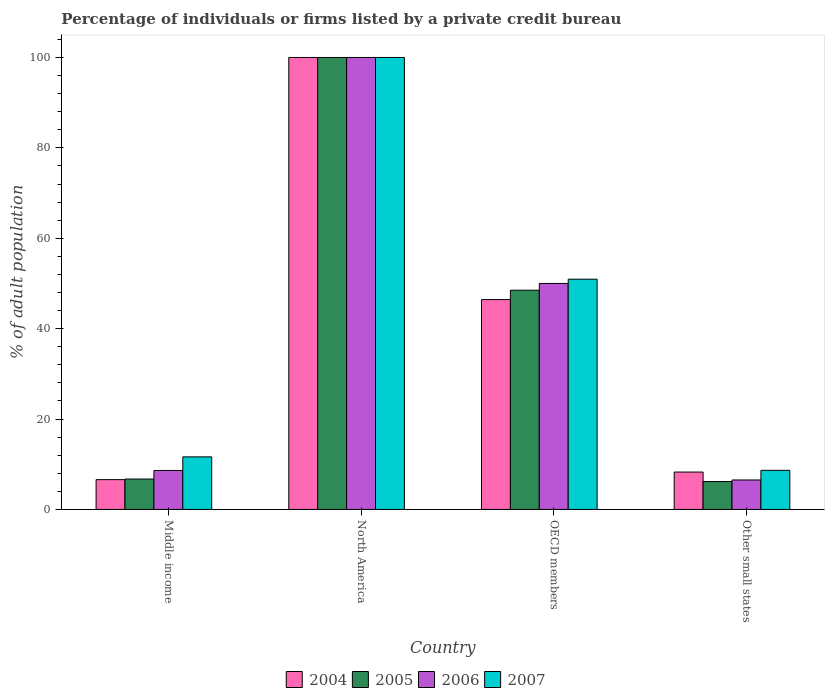How many different coloured bars are there?
Provide a succinct answer. 4. Are the number of bars per tick equal to the number of legend labels?
Give a very brief answer. Yes. Are the number of bars on each tick of the X-axis equal?
Keep it short and to the point. Yes. How many bars are there on the 1st tick from the left?
Offer a terse response. 4. How many bars are there on the 3rd tick from the right?
Offer a terse response. 4. What is the label of the 2nd group of bars from the left?
Provide a succinct answer. North America. What is the percentage of population listed by a private credit bureau in 2004 in Other small states?
Your answer should be compact. 8.28. Across all countries, what is the minimum percentage of population listed by a private credit bureau in 2004?
Offer a very short reply. 6.6. In which country was the percentage of population listed by a private credit bureau in 2004 maximum?
Your answer should be very brief. North America. In which country was the percentage of population listed by a private credit bureau in 2004 minimum?
Offer a terse response. Middle income. What is the total percentage of population listed by a private credit bureau in 2007 in the graph?
Keep it short and to the point. 171.24. What is the difference between the percentage of population listed by a private credit bureau in 2004 in North America and that in Other small states?
Make the answer very short. 91.72. What is the difference between the percentage of population listed by a private credit bureau in 2007 in Other small states and the percentage of population listed by a private credit bureau in 2004 in Middle income?
Provide a succinct answer. 2.06. What is the average percentage of population listed by a private credit bureau in 2004 per country?
Give a very brief answer. 40.33. What is the difference between the percentage of population listed by a private credit bureau of/in 2004 and percentage of population listed by a private credit bureau of/in 2005 in OECD members?
Your response must be concise. -2.07. What is the ratio of the percentage of population listed by a private credit bureau in 2005 in Middle income to that in OECD members?
Give a very brief answer. 0.14. Is the difference between the percentage of population listed by a private credit bureau in 2004 in OECD members and Other small states greater than the difference between the percentage of population listed by a private credit bureau in 2005 in OECD members and Other small states?
Your answer should be very brief. No. What is the difference between the highest and the second highest percentage of population listed by a private credit bureau in 2005?
Ensure brevity in your answer.  -51.5. What is the difference between the highest and the lowest percentage of population listed by a private credit bureau in 2007?
Your answer should be very brief. 91.34. What does the 3rd bar from the left in Other small states represents?
Your answer should be compact. 2006. What does the 3rd bar from the right in Middle income represents?
Give a very brief answer. 2005. Is it the case that in every country, the sum of the percentage of population listed by a private credit bureau in 2007 and percentage of population listed by a private credit bureau in 2004 is greater than the percentage of population listed by a private credit bureau in 2005?
Your response must be concise. Yes. How many bars are there?
Offer a very short reply. 16. Are all the bars in the graph horizontal?
Make the answer very short. No. What is the difference between two consecutive major ticks on the Y-axis?
Offer a terse response. 20. Are the values on the major ticks of Y-axis written in scientific E-notation?
Keep it short and to the point. No. Does the graph contain any zero values?
Give a very brief answer. No. Does the graph contain grids?
Give a very brief answer. No. Where does the legend appear in the graph?
Offer a very short reply. Bottom center. How many legend labels are there?
Offer a very short reply. 4. How are the legend labels stacked?
Give a very brief answer. Horizontal. What is the title of the graph?
Keep it short and to the point. Percentage of individuals or firms listed by a private credit bureau. What is the label or title of the X-axis?
Keep it short and to the point. Country. What is the label or title of the Y-axis?
Give a very brief answer. % of adult population. What is the % of adult population in 2004 in Middle income?
Your response must be concise. 6.6. What is the % of adult population of 2005 in Middle income?
Your answer should be compact. 6.73. What is the % of adult population in 2006 in Middle income?
Give a very brief answer. 8.62. What is the % of adult population in 2007 in Middle income?
Provide a succinct answer. 11.63. What is the % of adult population in 2006 in North America?
Offer a terse response. 100. What is the % of adult population of 2007 in North America?
Your answer should be compact. 100. What is the % of adult population of 2004 in OECD members?
Provide a succinct answer. 46.43. What is the % of adult population in 2005 in OECD members?
Keep it short and to the point. 48.5. What is the % of adult population in 2006 in OECD members?
Offer a terse response. 50. What is the % of adult population in 2007 in OECD members?
Your response must be concise. 50.95. What is the % of adult population of 2004 in Other small states?
Provide a succinct answer. 8.28. What is the % of adult population in 2005 in Other small states?
Provide a succinct answer. 6.18. What is the % of adult population in 2006 in Other small states?
Provide a short and direct response. 6.52. What is the % of adult population of 2007 in Other small states?
Provide a succinct answer. 8.66. Across all countries, what is the maximum % of adult population of 2004?
Keep it short and to the point. 100. Across all countries, what is the minimum % of adult population in 2004?
Provide a short and direct response. 6.6. Across all countries, what is the minimum % of adult population of 2005?
Offer a very short reply. 6.18. Across all countries, what is the minimum % of adult population in 2006?
Provide a short and direct response. 6.52. Across all countries, what is the minimum % of adult population in 2007?
Keep it short and to the point. 8.66. What is the total % of adult population in 2004 in the graph?
Give a very brief answer. 161.3. What is the total % of adult population of 2005 in the graph?
Keep it short and to the point. 161.41. What is the total % of adult population in 2006 in the graph?
Offer a terse response. 165.15. What is the total % of adult population of 2007 in the graph?
Offer a very short reply. 171.24. What is the difference between the % of adult population of 2004 in Middle income and that in North America?
Your response must be concise. -93.4. What is the difference between the % of adult population in 2005 in Middle income and that in North America?
Provide a succinct answer. -93.27. What is the difference between the % of adult population in 2006 in Middle income and that in North America?
Offer a terse response. -91.38. What is the difference between the % of adult population of 2007 in Middle income and that in North America?
Keep it short and to the point. -88.37. What is the difference between the % of adult population of 2004 in Middle income and that in OECD members?
Your response must be concise. -39.84. What is the difference between the % of adult population in 2005 in Middle income and that in OECD members?
Your answer should be compact. -41.77. What is the difference between the % of adult population of 2006 in Middle income and that in OECD members?
Your response must be concise. -41.38. What is the difference between the % of adult population in 2007 in Middle income and that in OECD members?
Your response must be concise. -39.31. What is the difference between the % of adult population of 2004 in Middle income and that in Other small states?
Your response must be concise. -1.68. What is the difference between the % of adult population in 2005 in Middle income and that in Other small states?
Offer a very short reply. 0.55. What is the difference between the % of adult population of 2006 in Middle income and that in Other small states?
Offer a very short reply. 2.1. What is the difference between the % of adult population in 2007 in Middle income and that in Other small states?
Offer a very short reply. 2.98. What is the difference between the % of adult population in 2004 in North America and that in OECD members?
Keep it short and to the point. 53.57. What is the difference between the % of adult population in 2005 in North America and that in OECD members?
Give a very brief answer. 51.5. What is the difference between the % of adult population in 2006 in North America and that in OECD members?
Make the answer very short. 50. What is the difference between the % of adult population in 2007 in North America and that in OECD members?
Offer a very short reply. 49.05. What is the difference between the % of adult population of 2004 in North America and that in Other small states?
Your answer should be compact. 91.72. What is the difference between the % of adult population in 2005 in North America and that in Other small states?
Provide a succinct answer. 93.82. What is the difference between the % of adult population in 2006 in North America and that in Other small states?
Offer a very short reply. 93.48. What is the difference between the % of adult population of 2007 in North America and that in Other small states?
Provide a succinct answer. 91.34. What is the difference between the % of adult population in 2004 in OECD members and that in Other small states?
Provide a succinct answer. 38.16. What is the difference between the % of adult population of 2005 in OECD members and that in Other small states?
Offer a very short reply. 42.33. What is the difference between the % of adult population of 2006 in OECD members and that in Other small states?
Your answer should be very brief. 43.48. What is the difference between the % of adult population in 2007 in OECD members and that in Other small states?
Your answer should be very brief. 42.29. What is the difference between the % of adult population of 2004 in Middle income and the % of adult population of 2005 in North America?
Provide a short and direct response. -93.4. What is the difference between the % of adult population in 2004 in Middle income and the % of adult population in 2006 in North America?
Make the answer very short. -93.4. What is the difference between the % of adult population of 2004 in Middle income and the % of adult population of 2007 in North America?
Your response must be concise. -93.4. What is the difference between the % of adult population of 2005 in Middle income and the % of adult population of 2006 in North America?
Make the answer very short. -93.27. What is the difference between the % of adult population of 2005 in Middle income and the % of adult population of 2007 in North America?
Give a very brief answer. -93.27. What is the difference between the % of adult population of 2006 in Middle income and the % of adult population of 2007 in North America?
Give a very brief answer. -91.38. What is the difference between the % of adult population of 2004 in Middle income and the % of adult population of 2005 in OECD members?
Give a very brief answer. -41.91. What is the difference between the % of adult population of 2004 in Middle income and the % of adult population of 2006 in OECD members?
Provide a succinct answer. -43.4. What is the difference between the % of adult population of 2004 in Middle income and the % of adult population of 2007 in OECD members?
Your answer should be very brief. -44.35. What is the difference between the % of adult population of 2005 in Middle income and the % of adult population of 2006 in OECD members?
Your response must be concise. -43.27. What is the difference between the % of adult population in 2005 in Middle income and the % of adult population in 2007 in OECD members?
Offer a terse response. -44.22. What is the difference between the % of adult population in 2006 in Middle income and the % of adult population in 2007 in OECD members?
Provide a succinct answer. -42.32. What is the difference between the % of adult population in 2004 in Middle income and the % of adult population in 2005 in Other small states?
Your answer should be compact. 0.42. What is the difference between the % of adult population of 2004 in Middle income and the % of adult population of 2006 in Other small states?
Provide a succinct answer. 0.07. What is the difference between the % of adult population in 2004 in Middle income and the % of adult population in 2007 in Other small states?
Give a very brief answer. -2.06. What is the difference between the % of adult population of 2005 in Middle income and the % of adult population of 2006 in Other small states?
Provide a short and direct response. 0.21. What is the difference between the % of adult population of 2005 in Middle income and the % of adult population of 2007 in Other small states?
Provide a succinct answer. -1.93. What is the difference between the % of adult population of 2006 in Middle income and the % of adult population of 2007 in Other small states?
Offer a terse response. -0.03. What is the difference between the % of adult population in 2004 in North America and the % of adult population in 2005 in OECD members?
Offer a very short reply. 51.5. What is the difference between the % of adult population of 2004 in North America and the % of adult population of 2006 in OECD members?
Keep it short and to the point. 50. What is the difference between the % of adult population in 2004 in North America and the % of adult population in 2007 in OECD members?
Your answer should be compact. 49.05. What is the difference between the % of adult population in 2005 in North America and the % of adult population in 2006 in OECD members?
Your answer should be very brief. 50. What is the difference between the % of adult population in 2005 in North America and the % of adult population in 2007 in OECD members?
Your answer should be compact. 49.05. What is the difference between the % of adult population in 2006 in North America and the % of adult population in 2007 in OECD members?
Offer a terse response. 49.05. What is the difference between the % of adult population of 2004 in North America and the % of adult population of 2005 in Other small states?
Make the answer very short. 93.82. What is the difference between the % of adult population of 2004 in North America and the % of adult population of 2006 in Other small states?
Provide a succinct answer. 93.48. What is the difference between the % of adult population of 2004 in North America and the % of adult population of 2007 in Other small states?
Offer a very short reply. 91.34. What is the difference between the % of adult population of 2005 in North America and the % of adult population of 2006 in Other small states?
Your answer should be very brief. 93.48. What is the difference between the % of adult population of 2005 in North America and the % of adult population of 2007 in Other small states?
Provide a succinct answer. 91.34. What is the difference between the % of adult population of 2006 in North America and the % of adult population of 2007 in Other small states?
Offer a terse response. 91.34. What is the difference between the % of adult population in 2004 in OECD members and the % of adult population in 2005 in Other small states?
Your answer should be compact. 40.26. What is the difference between the % of adult population of 2004 in OECD members and the % of adult population of 2006 in Other small states?
Make the answer very short. 39.91. What is the difference between the % of adult population of 2004 in OECD members and the % of adult population of 2007 in Other small states?
Keep it short and to the point. 37.78. What is the difference between the % of adult population of 2005 in OECD members and the % of adult population of 2006 in Other small states?
Your response must be concise. 41.98. What is the difference between the % of adult population in 2005 in OECD members and the % of adult population in 2007 in Other small states?
Give a very brief answer. 39.85. What is the difference between the % of adult population in 2006 in OECD members and the % of adult population in 2007 in Other small states?
Your answer should be very brief. 41.34. What is the average % of adult population of 2004 per country?
Offer a very short reply. 40.33. What is the average % of adult population of 2005 per country?
Your response must be concise. 40.35. What is the average % of adult population of 2006 per country?
Give a very brief answer. 41.29. What is the average % of adult population in 2007 per country?
Ensure brevity in your answer.  42.81. What is the difference between the % of adult population of 2004 and % of adult population of 2005 in Middle income?
Provide a succinct answer. -0.13. What is the difference between the % of adult population of 2004 and % of adult population of 2006 in Middle income?
Ensure brevity in your answer.  -2.03. What is the difference between the % of adult population of 2004 and % of adult population of 2007 in Middle income?
Offer a terse response. -5.04. What is the difference between the % of adult population of 2005 and % of adult population of 2006 in Middle income?
Your response must be concise. -1.9. What is the difference between the % of adult population in 2005 and % of adult population in 2007 in Middle income?
Provide a short and direct response. -4.91. What is the difference between the % of adult population in 2006 and % of adult population in 2007 in Middle income?
Provide a succinct answer. -3.01. What is the difference between the % of adult population in 2004 and % of adult population in 2007 in North America?
Make the answer very short. 0. What is the difference between the % of adult population of 2004 and % of adult population of 2005 in OECD members?
Your answer should be compact. -2.07. What is the difference between the % of adult population of 2004 and % of adult population of 2006 in OECD members?
Provide a short and direct response. -3.57. What is the difference between the % of adult population in 2004 and % of adult population in 2007 in OECD members?
Keep it short and to the point. -4.51. What is the difference between the % of adult population in 2005 and % of adult population in 2006 in OECD members?
Give a very brief answer. -1.5. What is the difference between the % of adult population in 2005 and % of adult population in 2007 in OECD members?
Give a very brief answer. -2.44. What is the difference between the % of adult population in 2006 and % of adult population in 2007 in OECD members?
Your answer should be very brief. -0.95. What is the difference between the % of adult population in 2004 and % of adult population in 2005 in Other small states?
Keep it short and to the point. 2.1. What is the difference between the % of adult population in 2004 and % of adult population in 2006 in Other small states?
Your answer should be compact. 1.75. What is the difference between the % of adult population of 2004 and % of adult population of 2007 in Other small states?
Ensure brevity in your answer.  -0.38. What is the difference between the % of adult population of 2005 and % of adult population of 2006 in Other small states?
Your response must be concise. -0.35. What is the difference between the % of adult population of 2005 and % of adult population of 2007 in Other small states?
Your answer should be very brief. -2.48. What is the difference between the % of adult population of 2006 and % of adult population of 2007 in Other small states?
Your response must be concise. -2.13. What is the ratio of the % of adult population of 2004 in Middle income to that in North America?
Offer a terse response. 0.07. What is the ratio of the % of adult population in 2005 in Middle income to that in North America?
Provide a succinct answer. 0.07. What is the ratio of the % of adult population in 2006 in Middle income to that in North America?
Ensure brevity in your answer.  0.09. What is the ratio of the % of adult population in 2007 in Middle income to that in North America?
Provide a short and direct response. 0.12. What is the ratio of the % of adult population in 2004 in Middle income to that in OECD members?
Ensure brevity in your answer.  0.14. What is the ratio of the % of adult population of 2005 in Middle income to that in OECD members?
Provide a short and direct response. 0.14. What is the ratio of the % of adult population of 2006 in Middle income to that in OECD members?
Your answer should be compact. 0.17. What is the ratio of the % of adult population in 2007 in Middle income to that in OECD members?
Provide a short and direct response. 0.23. What is the ratio of the % of adult population in 2004 in Middle income to that in Other small states?
Give a very brief answer. 0.8. What is the ratio of the % of adult population in 2005 in Middle income to that in Other small states?
Give a very brief answer. 1.09. What is the ratio of the % of adult population of 2006 in Middle income to that in Other small states?
Your answer should be compact. 1.32. What is the ratio of the % of adult population of 2007 in Middle income to that in Other small states?
Offer a terse response. 1.34. What is the ratio of the % of adult population of 2004 in North America to that in OECD members?
Offer a terse response. 2.15. What is the ratio of the % of adult population of 2005 in North America to that in OECD members?
Provide a succinct answer. 2.06. What is the ratio of the % of adult population in 2006 in North America to that in OECD members?
Offer a terse response. 2. What is the ratio of the % of adult population of 2007 in North America to that in OECD members?
Give a very brief answer. 1.96. What is the ratio of the % of adult population of 2004 in North America to that in Other small states?
Make the answer very short. 12.08. What is the ratio of the % of adult population of 2005 in North America to that in Other small states?
Offer a very short reply. 16.19. What is the ratio of the % of adult population of 2006 in North America to that in Other small states?
Keep it short and to the point. 15.33. What is the ratio of the % of adult population of 2007 in North America to that in Other small states?
Your answer should be very brief. 11.55. What is the ratio of the % of adult population of 2004 in OECD members to that in Other small states?
Make the answer very short. 5.61. What is the ratio of the % of adult population of 2005 in OECD members to that in Other small states?
Your answer should be very brief. 7.85. What is the ratio of the % of adult population in 2006 in OECD members to that in Other small states?
Your response must be concise. 7.67. What is the ratio of the % of adult population in 2007 in OECD members to that in Other small states?
Make the answer very short. 5.89. What is the difference between the highest and the second highest % of adult population in 2004?
Your answer should be compact. 53.57. What is the difference between the highest and the second highest % of adult population in 2005?
Your response must be concise. 51.5. What is the difference between the highest and the second highest % of adult population in 2007?
Your response must be concise. 49.05. What is the difference between the highest and the lowest % of adult population of 2004?
Give a very brief answer. 93.4. What is the difference between the highest and the lowest % of adult population in 2005?
Give a very brief answer. 93.82. What is the difference between the highest and the lowest % of adult population of 2006?
Give a very brief answer. 93.48. What is the difference between the highest and the lowest % of adult population in 2007?
Your answer should be compact. 91.34. 